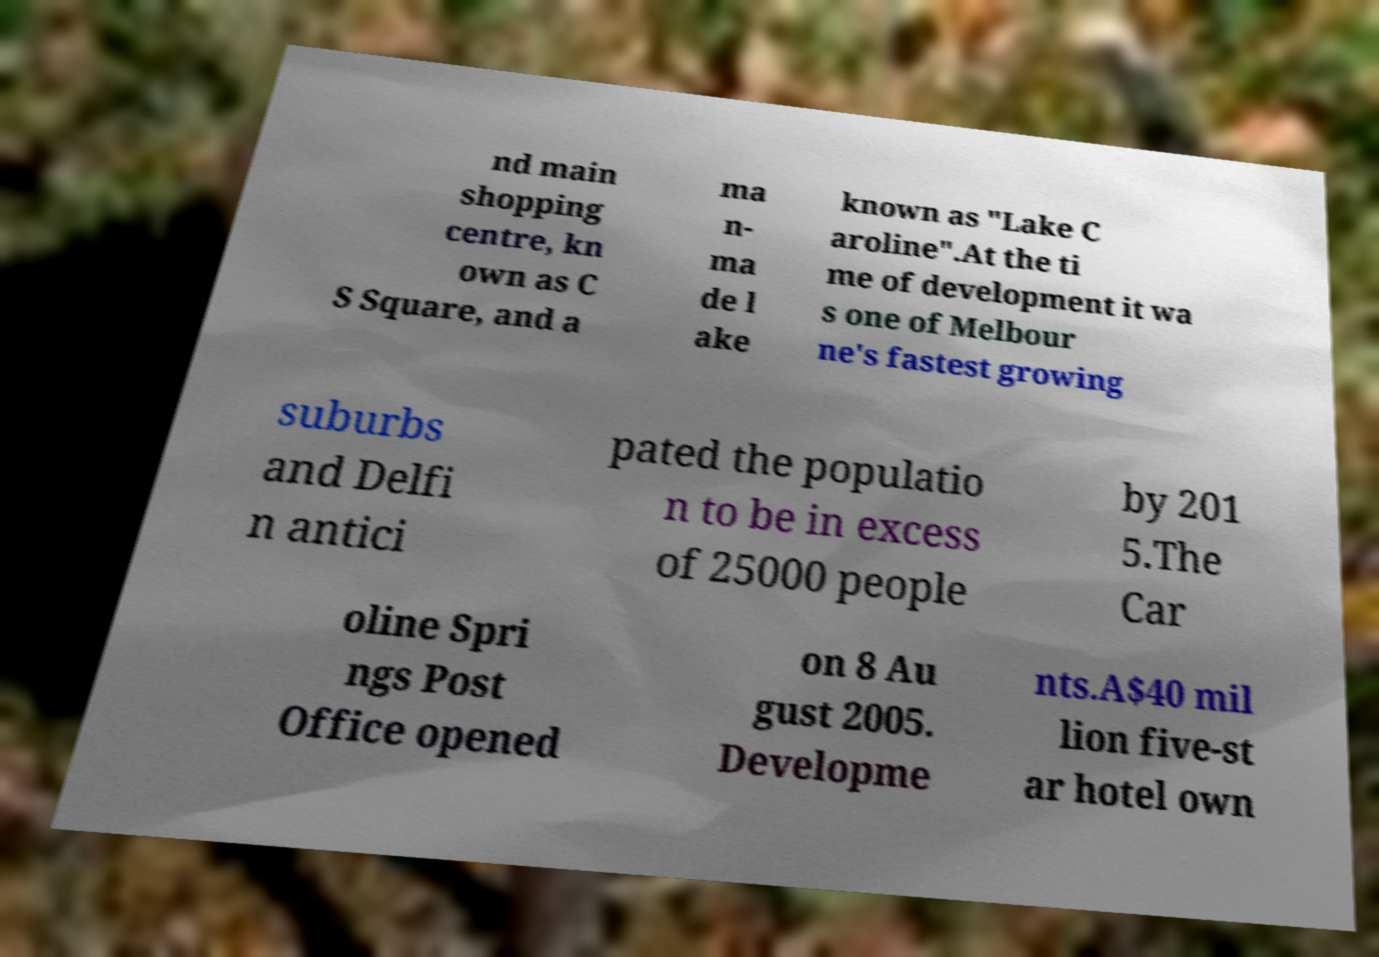Could you assist in decoding the text presented in this image and type it out clearly? nd main shopping centre, kn own as C S Square, and a ma n- ma de l ake known as "Lake C aroline".At the ti me of development it wa s one of Melbour ne's fastest growing suburbs and Delfi n antici pated the populatio n to be in excess of 25000 people by 201 5.The Car oline Spri ngs Post Office opened on 8 Au gust 2005. Developme nts.A$40 mil lion five-st ar hotel own 